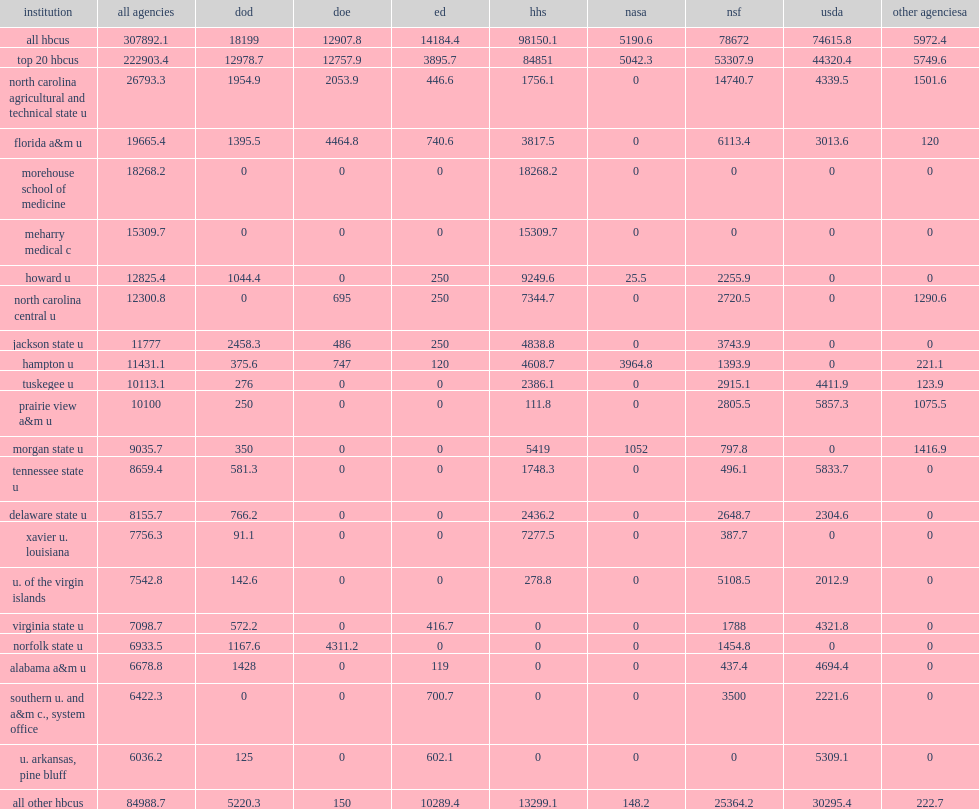I'm looking to parse the entire table for insights. Could you assist me with that? {'header': ['institution', 'all agencies', 'dod', 'doe', 'ed', 'hhs', 'nasa', 'nsf', 'usda', 'other agenciesa'], 'rows': [['all hbcus', '307892.1', '18199', '12907.8', '14184.4', '98150.1', '5190.6', '78672', '74615.8', '5972.4'], ['top 20 hbcus', '222903.4', '12978.7', '12757.9', '3895.7', '84851', '5042.3', '53307.9', '44320.4', '5749.6'], ['north carolina agricultural and technical state u', '26793.3', '1954.9', '2053.9', '446.6', '1756.1', '0', '14740.7', '4339.5', '1501.6'], ['florida a&m u', '19665.4', '1395.5', '4464.8', '740.6', '3817.5', '0', '6113.4', '3013.6', '120'], ['morehouse school of medicine', '18268.2', '0', '0', '0', '18268.2', '0', '0', '0', '0'], ['meharry medical c', '15309.7', '0', '0', '0', '15309.7', '0', '0', '0', '0'], ['howard u', '12825.4', '1044.4', '0', '250', '9249.6', '25.5', '2255.9', '0', '0'], ['north carolina central u', '12300.8', '0', '695', '250', '7344.7', '0', '2720.5', '0', '1290.6'], ['jackson state u', '11777', '2458.3', '486', '250', '4838.8', '0', '3743.9', '0', '0'], ['hampton u', '11431.1', '375.6', '747', '120', '4608.7', '3964.8', '1393.9', '0', '221.1'], ['tuskegee u', '10113.1', '276', '0', '0', '2386.1', '0', '2915.1', '4411.9', '123.9'], ['prairie view a&m u', '10100', '250', '0', '0', '111.8', '0', '2805.5', '5857.3', '1075.5'], ['morgan state u', '9035.7', '350', '0', '0', '5419', '1052', '797.8', '0', '1416.9'], ['tennessee state u', '8659.4', '581.3', '0', '0', '1748.3', '0', '496.1', '5833.7', '0'], ['delaware state u', '8155.7', '766.2', '0', '0', '2436.2', '0', '2648.7', '2304.6', '0'], ['xavier u. louisiana', '7756.3', '91.1', '0', '0', '7277.5', '0', '387.7', '0', '0'], ['u. of the virgin islands', '7542.8', '142.6', '0', '0', '278.8', '0', '5108.5', '2012.9', '0'], ['virginia state u', '7098.7', '572.2', '0', '416.7', '0', '0', '1788', '4321.8', '0'], ['norfolk state u', '6933.5', '1167.6', '4311.2', '0', '0', '0', '1454.8', '0', '0'], ['alabama a&m u', '6678.8', '1428', '0', '119', '0', '0', '437.4', '4694.4', '0'], ['southern u. and a&m c., system office', '6422.3', '0', '0', '700.7', '0', '0', '3500', '2221.6', '0'], ['u. arkansas, pine bluff', '6036.2', '125', '0', '602.1', '0', '0', '0', '5309.1', '0'], ['all other hbcus', '84988.7', '5220.3', '150', '10289.4', '13299.1', '148.2', '25364.2', '30295.4', '222.7']]} In fy 2017, how many percentage points did five federal agencies account of all federal obligations for s&e support to hbcus? 0.921821. How many million dollars did hhs provide the most s&e support accounting of all federal hbcu obligations? 98150.1. How many percentage points did hhs which provided the most s&e support account of all federal hbcu obligations? 0.318781. How many thousand dollars did nsf provide thousand in s&e support? 78672.0. How many percentage points did nsf which provided $79 million in s&e support account of all federal hbcu obligations? 0.255518. How many thousand dollars did usda provide in s&e support? 74615.8. How many percentage points did usda which provided $75 million in s&e support account of all federal hbcu obligations? 0.242344. 